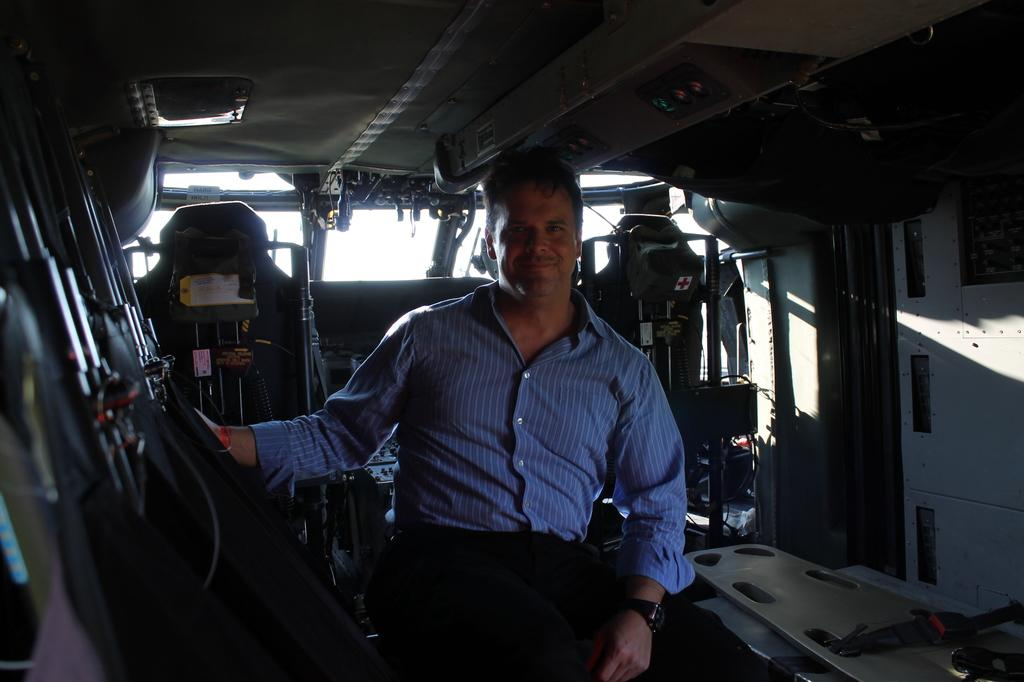What is the person in the image doing? There is a person sitting in the vehicle. What can be found inside the vehicle? There are seats in the vehicle. What part of the vehicle's interior is visible? The ceiling of the vehicle is visible. What is attached to the ceiling of the vehicle? There is a light attached to the ceiling. What other items can be seen inside the vehicle? There are other objects present in the vehicle. What type of development is taking place near the vehicle in the image? There is no indication of any development taking place near the vehicle in the image. 